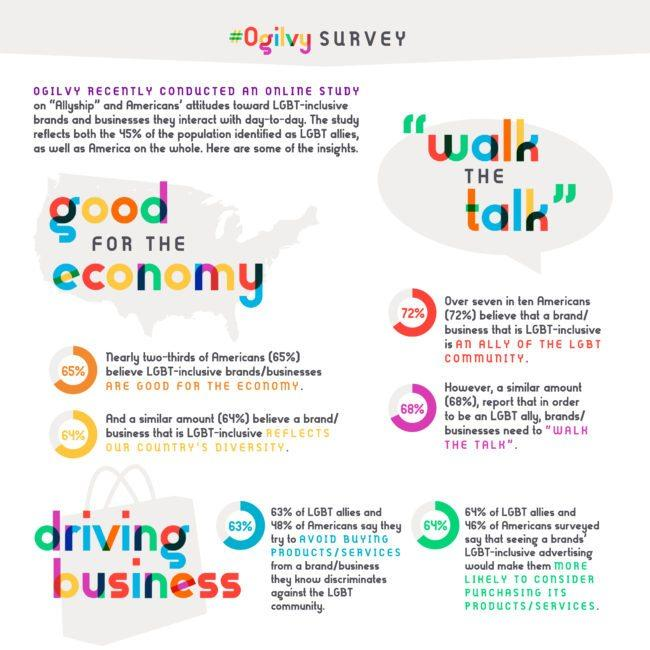Outline some significant characteristics in this image. A significant 48% of Americans are not interested in purchasing products or services from a brand that discriminates against the LGBT community. A survey found that 63% of LGBT allies do not purchase products or services from brands that discriminate against the LGBT community. Sixty-four percent of LGBT allies are interested in purchasing products and services from a brand that is promoted by the LGBT community. According to recent polls, 35% of Americans do not believe that LGBT-inclusive brands are good for the economy. According to the survey, 46% of Americans are more likely to purchase products and services from a brand that is promoted by the LGBT community. 